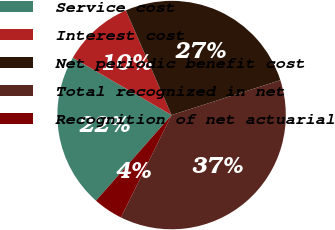Convert chart to OTSL. <chart><loc_0><loc_0><loc_500><loc_500><pie_chart><fcel>Service cost<fcel>Interest cost<fcel>Net periodic benefit cost<fcel>Total recognized in net<fcel>Recognition of net actuarial<nl><fcel>21.85%<fcel>10.08%<fcel>26.61%<fcel>37.25%<fcel>4.2%<nl></chart> 